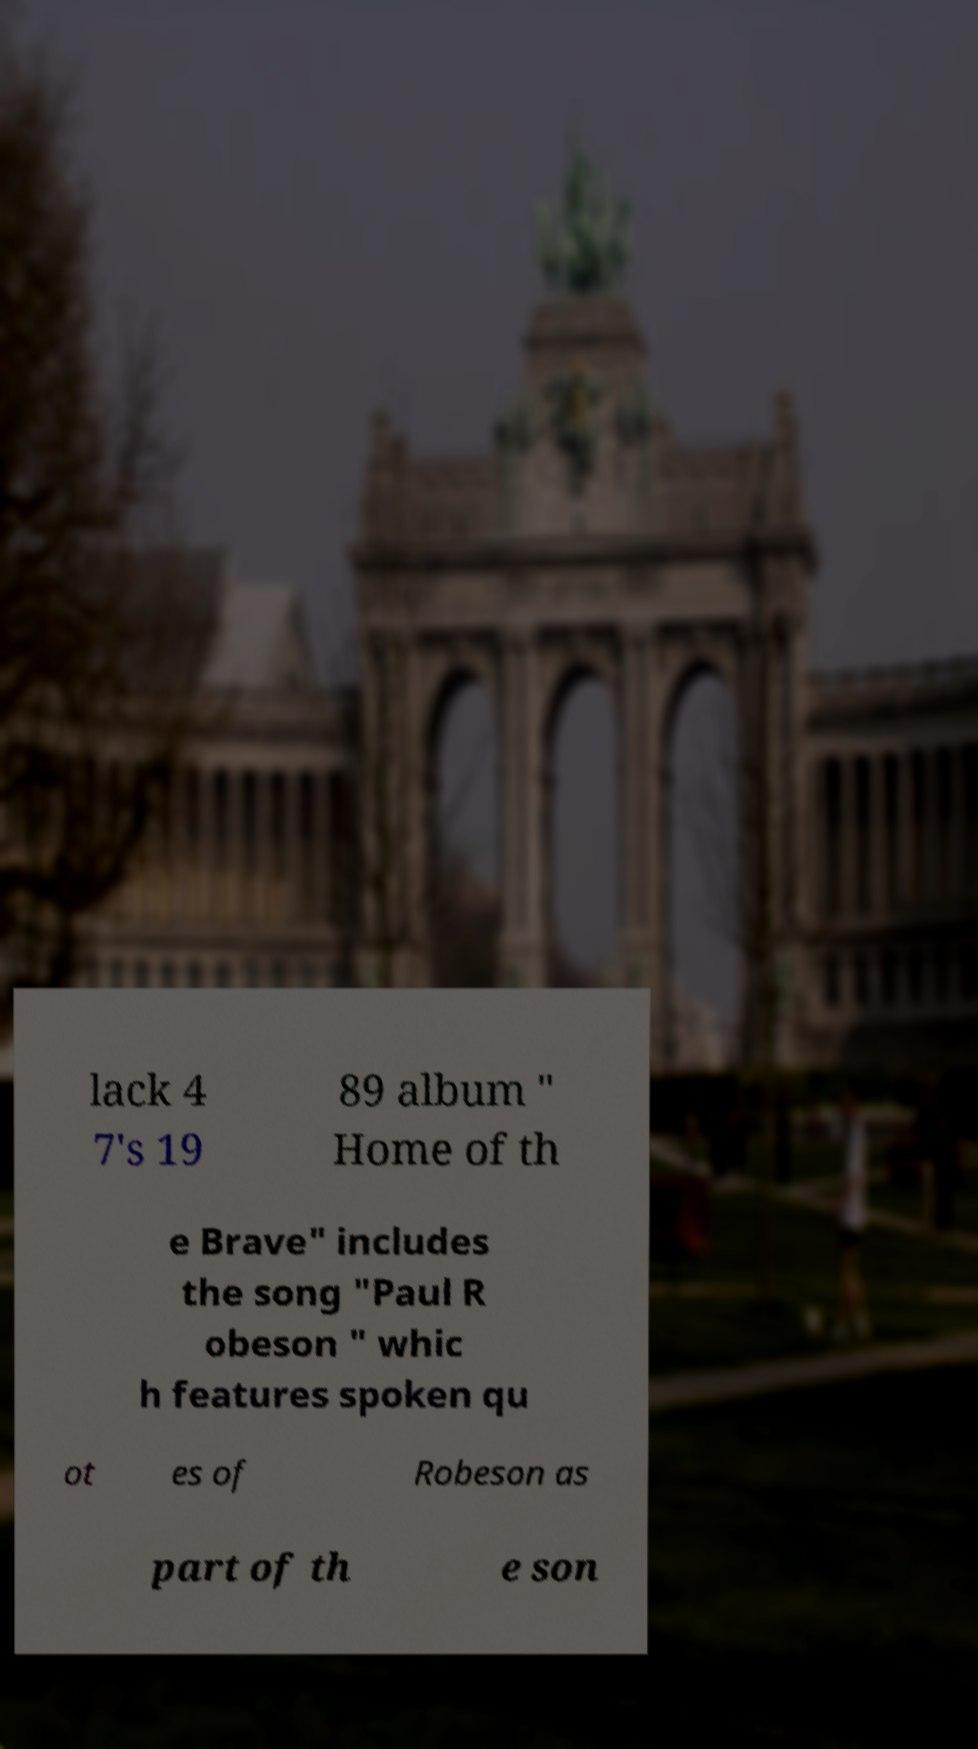Could you assist in decoding the text presented in this image and type it out clearly? lack 4 7's 19 89 album " Home of th e Brave" includes the song "Paul R obeson " whic h features spoken qu ot es of Robeson as part of th e son 